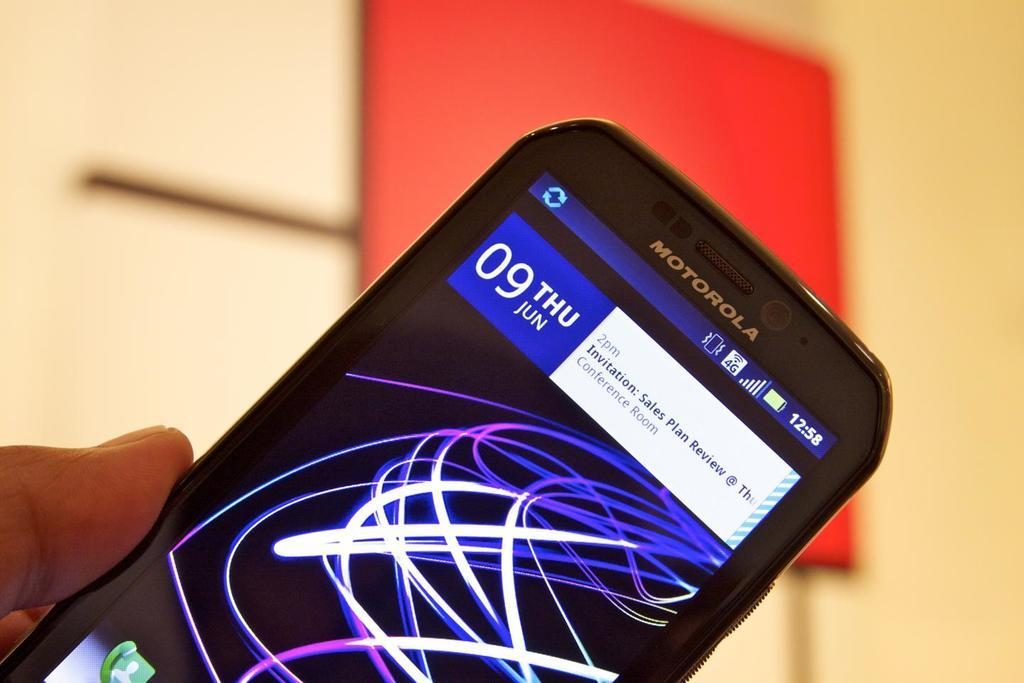<image>
Summarize the visual content of the image. Fingers holding a cell phone that has a calendar reminder on it that says 2pm Invitation: Sales Plan Review. 